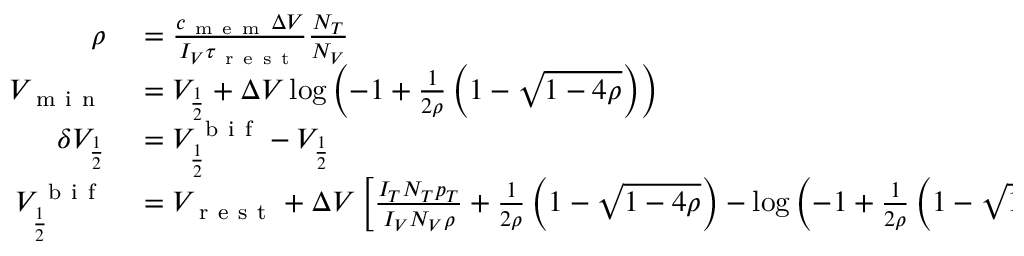Convert formula to latex. <formula><loc_0><loc_0><loc_500><loc_500>\begin{array} { r l } { \rho } & = \frac { c _ { m e m } \Delta V } { I _ { V } \tau _ { r e s t } } \frac { N _ { T } } { N _ { V } } } \\ { V _ { m i n } } & = V _ { \frac { 1 } { 2 } } + \Delta V \log \left ( - 1 + \frac { 1 } { 2 \rho } \left ( 1 - \sqrt { 1 - 4 \rho } \right ) \right ) } \\ { \delta V _ { \frac { 1 } { 2 } } } & = V _ { \frac { 1 } { 2 } } ^ { b i f } - V _ { \frac { 1 } { 2 } } } \\ { V _ { \frac { 1 } { 2 } } ^ { b i f } } & = V _ { r e s t } + \Delta V \left [ \frac { I _ { T } N _ { T } p _ { T } } { I _ { V } N _ { V } \rho } + \frac { 1 } { 2 \rho } \left ( 1 - \sqrt { 1 - 4 \rho } \right ) - \log \left ( - 1 + \frac { 1 } { 2 \rho } \left ( 1 - \sqrt { 1 - 4 \rho } \right ) \right ) \right ] . } \end{array}</formula> 